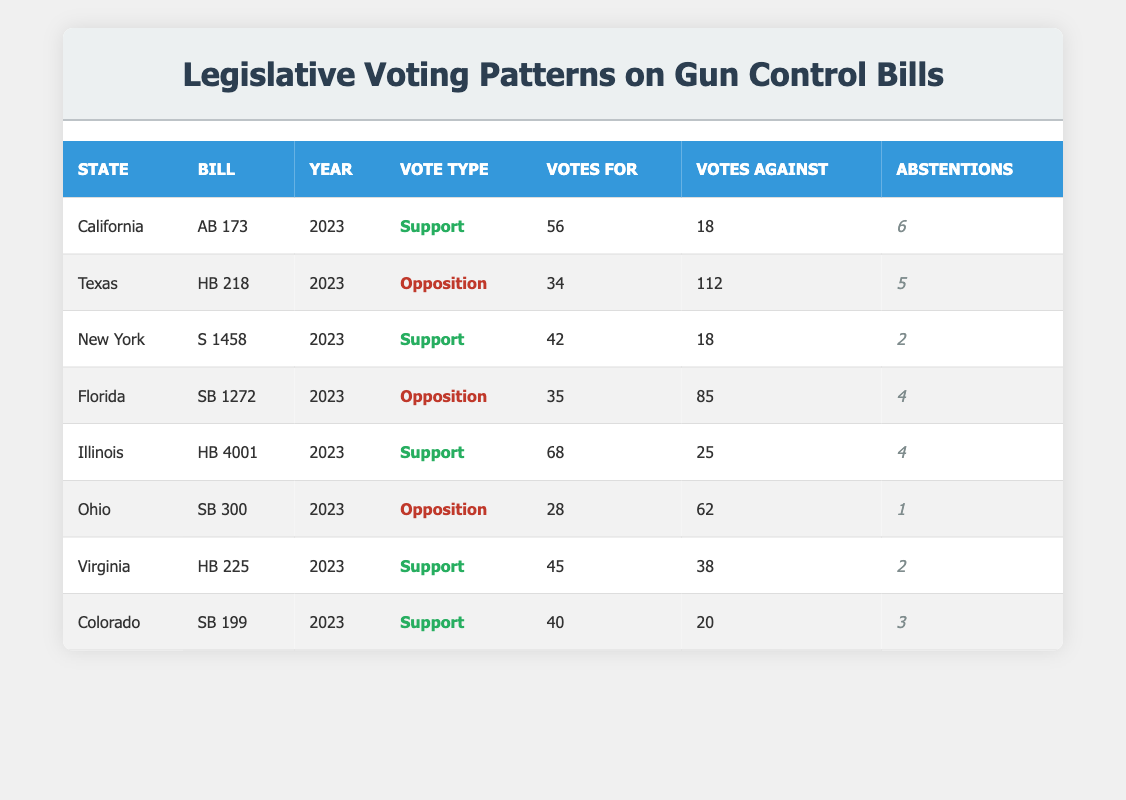What are the total votes against gun control bills in California? In the table, California's bill AB 173 had 18 votes against it in 2023. There are no other bills listed for California in the table, so the total votes against gun control bills in California is just 18.
Answer: 18 Which state had the highest number of votes in support of gun control bills? Looking through the table, Illinois had 68 votes in support for bill HB 4001, which is higher than any other state listed. California had 56, New York 42, Virginia 45, and Colorado 40. Therefore, Illinois has the highest support votes.
Answer: Illinois What is the total number of abstentions from the votes for all bills listed? To calculate total abstentions, we add the abstentions from each state: California (6) + Texas (5) + New York (2) + Florida (4) + Illinois (4) + Ohio (1) + Virginia (2) + Colorado (3) = 27. Thus, the total abstentions across all states is 27.
Answer: 27 Did Texas support any gun control bills in 2023? The data shows that Texas had bill HB 218, which was met with opposition (votes against: 112). There are no support votes for any gun control bills in Texas for 2023. Therefore, the answer is no.
Answer: No What percentage of votes against was recorded in New York for gun control measures? In New York, for bill S 1458, there were 18 votes against out of a total of 60 votes (42 votes for + 18 votes against). To calculate the percentage: (18 / 60) * 100 = 30%. So, the percentage of votes against gun control measures in New York is 30%.
Answer: 30% What was the difference in votes against between Texas and Florida regarding their gun control bills? Texas had 112 votes against (for HB 218), while Florida had 85 votes against (for SB 1272). To find the difference: 112 - 85 = 27 votes. Thus, the difference in votes against is 27.
Answer: 27 In which state was the total number of abstentions the lowest, and how many were there? The lowest abstentions in the table were from Ohio, which had only 1 abstention in SB 300. The other states had higher numbers of abstentions. Therefore, Ohio has the lowest total of 1.
Answer: Ohio, 1 Were there more votes in support or opposition to gun control bills overall across the listed states? Adding up the support votes: California (56) + New York (42) + Illinois (68) + Virginia (45) + Colorado (40) = 251 votes for. For opposition votes: Texas (112) + Florida (85) + Ohio (62) = 259 votes against. Since 259 is greater than 251, there were more votes in opposition overall.
Answer: Opposition Which bill had the most significant margin between votes for and against? The bills can be analyzed for the margin by subtracting votes against from votes for: California (56 - 18 = 38), Texas (34 - 112 = -78), New York (42 - 18 = 24), Florida (35 - 85 = -50), Illinois (68 - 25 = 43), Ohio (28 - 62 = -34), Virginia (45 - 38 = 7), Colorado (40 - 20 = 20). The largest positive margin is from Illinois (43), while Texas has the largest negative margin (-78). Therefore, Illinois had the most significant favorable margin with 43 votes.
Answer: Illinois, 43 